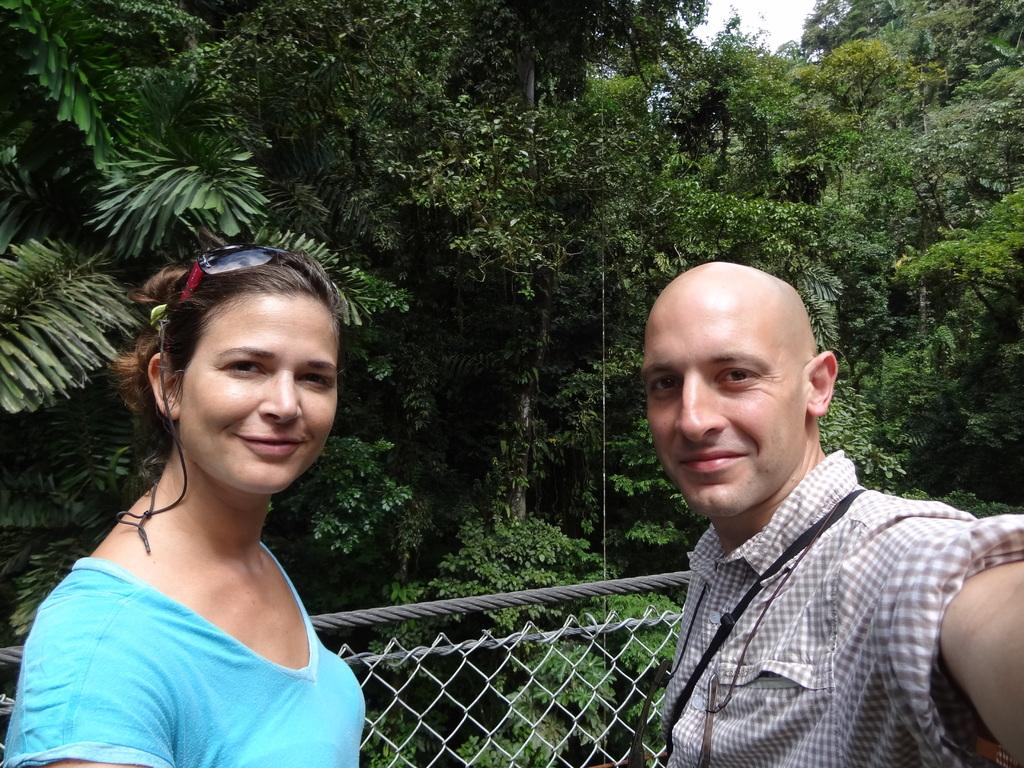How many people are in the image? There are two persons in the image. What can be seen in the background of the image? There is a fence and trees in the image. What is visible at the top of the image? The sky is visible in the image. How much dust can be seen on the persons in the image? There is no mention of dust in the image, so it cannot be determined how much dust is present. 